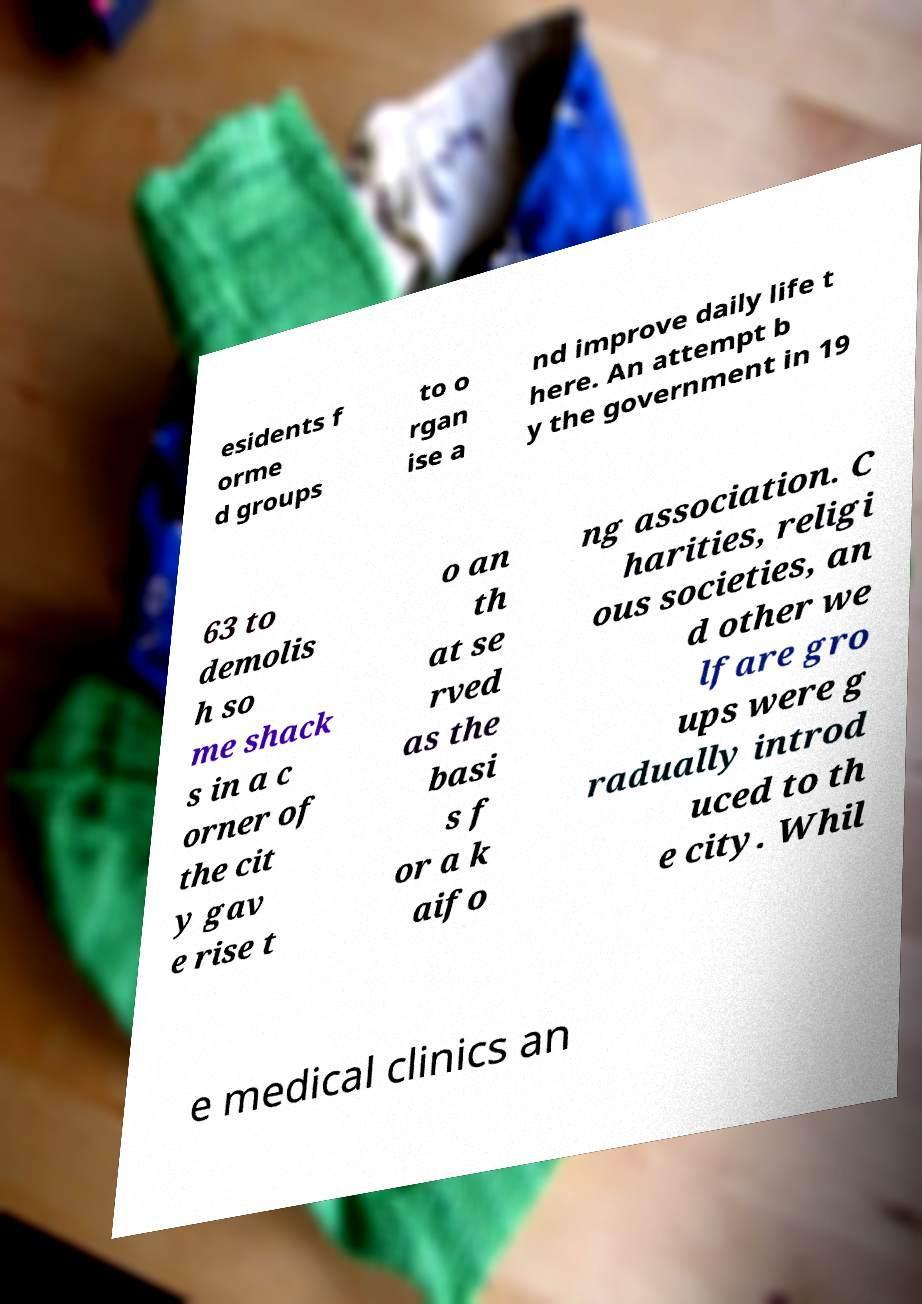What messages or text are displayed in this image? I need them in a readable, typed format. esidents f orme d groups to o rgan ise a nd improve daily life t here. An attempt b y the government in 19 63 to demolis h so me shack s in a c orner of the cit y gav e rise t o an th at se rved as the basi s f or a k aifo ng association. C harities, religi ous societies, an d other we lfare gro ups were g radually introd uced to th e city. Whil e medical clinics an 